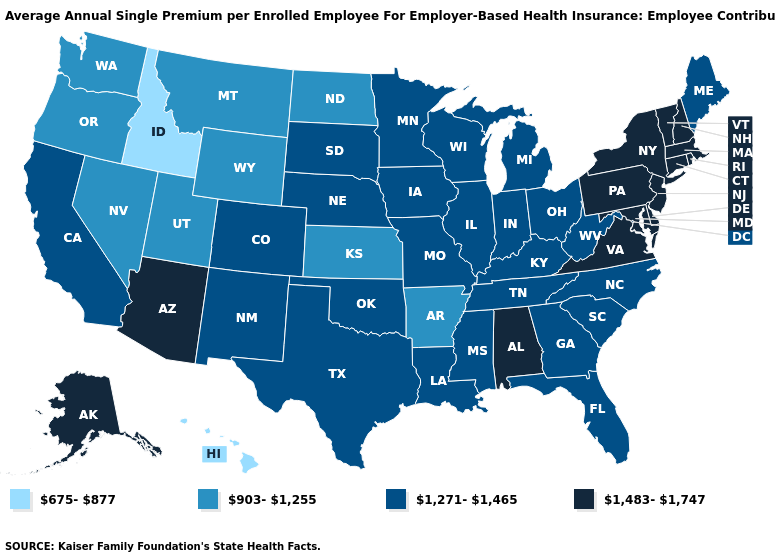Name the states that have a value in the range 903-1,255?
Quick response, please. Arkansas, Kansas, Montana, Nevada, North Dakota, Oregon, Utah, Washington, Wyoming. Does Hawaii have a lower value than Maryland?
Short answer required. Yes. Which states hav the highest value in the South?
Answer briefly. Alabama, Delaware, Maryland, Virginia. Does the map have missing data?
Concise answer only. No. Is the legend a continuous bar?
Concise answer only. No. Does Alaska have the highest value in the West?
Keep it brief. Yes. Does Florida have a higher value than Hawaii?
Answer briefly. Yes. Does Arizona have the highest value in the West?
Concise answer only. Yes. Which states hav the highest value in the West?
Write a very short answer. Alaska, Arizona. Does the first symbol in the legend represent the smallest category?
Short answer required. Yes. Name the states that have a value in the range 675-877?
Concise answer only. Hawaii, Idaho. Name the states that have a value in the range 1,483-1,747?
Concise answer only. Alabama, Alaska, Arizona, Connecticut, Delaware, Maryland, Massachusetts, New Hampshire, New Jersey, New York, Pennsylvania, Rhode Island, Vermont, Virginia. Does the first symbol in the legend represent the smallest category?
Answer briefly. Yes. Which states hav the highest value in the West?
Short answer required. Alaska, Arizona. What is the value of Maryland?
Give a very brief answer. 1,483-1,747. 